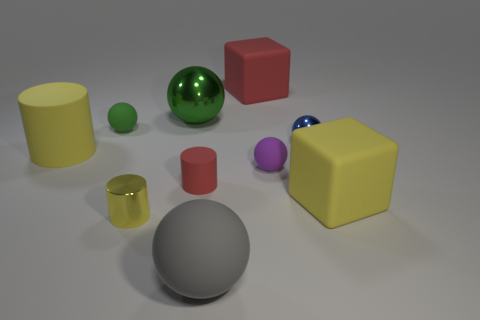Subtract all tiny cylinders. How many cylinders are left? 1 Subtract all blue balls. How many yellow cylinders are left? 2 Subtract all gray spheres. How many spheres are left? 4 Subtract all gray balls. Subtract all cyan cylinders. How many balls are left? 4 Subtract all cubes. How many objects are left? 8 Add 2 large blue spheres. How many large blue spheres exist? 2 Subtract 0 brown cubes. How many objects are left? 10 Subtract all cyan cubes. Subtract all big yellow blocks. How many objects are left? 9 Add 3 big rubber things. How many big rubber things are left? 7 